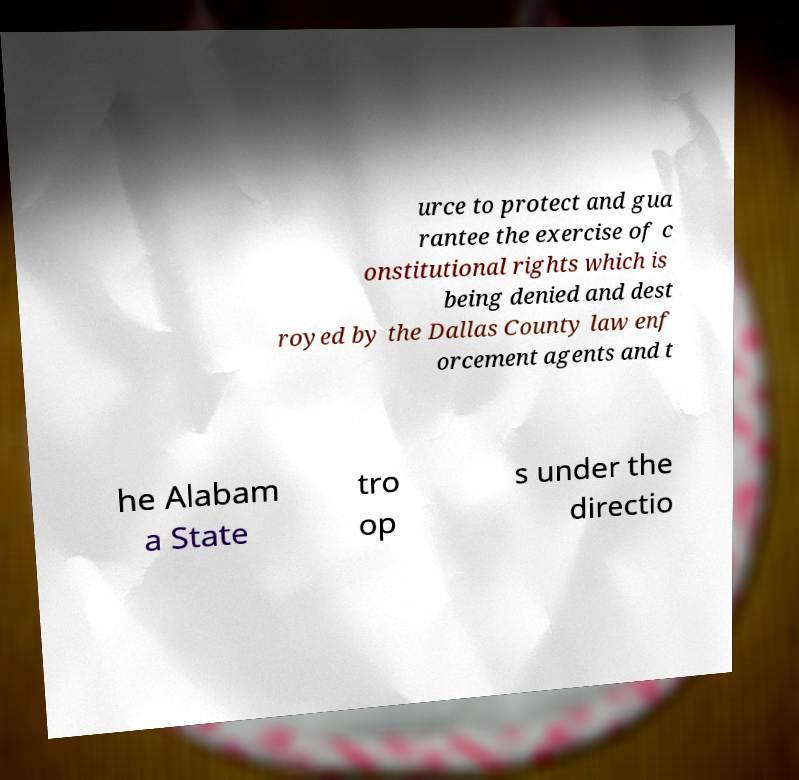Please identify and transcribe the text found in this image. urce to protect and gua rantee the exercise of c onstitutional rights which is being denied and dest royed by the Dallas County law enf orcement agents and t he Alabam a State tro op s under the directio 